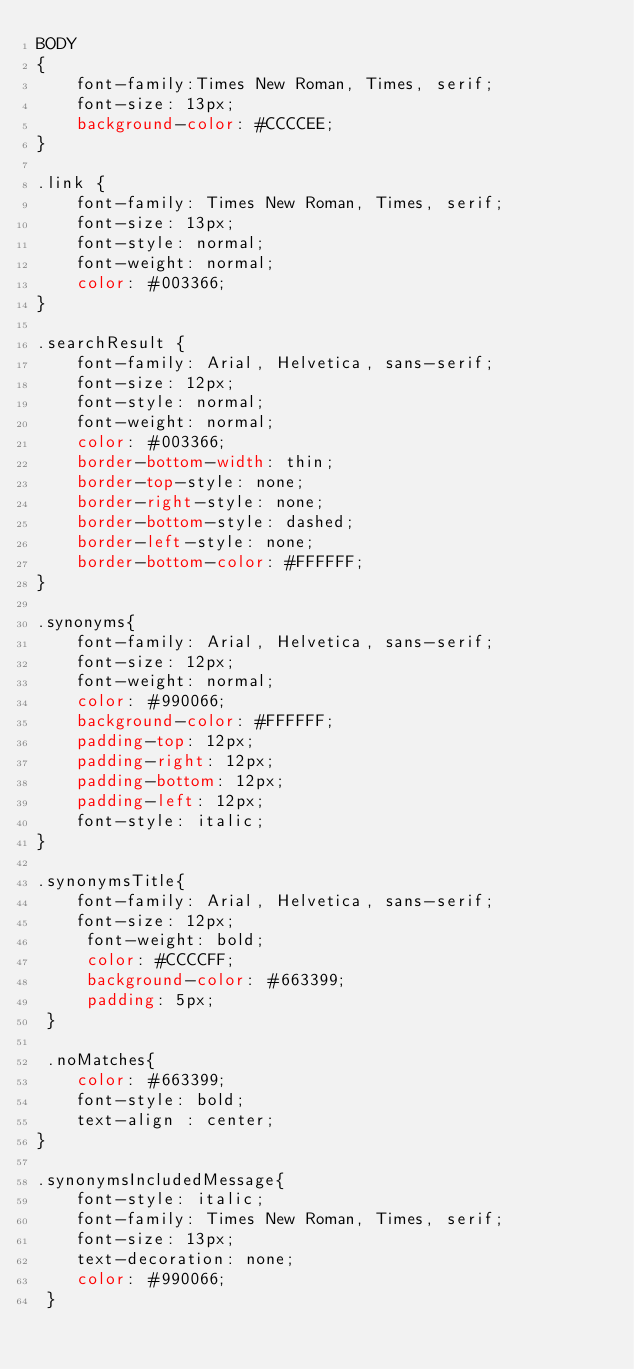<code> <loc_0><loc_0><loc_500><loc_500><_CSS_>BODY 
{
	font-family:Times New Roman, Times, serif;
	font-size: 13px;
	background-color: #CCCCEE;
}

.link {
	font-family: Times New Roman, Times, serif;
	font-size: 13px;
	font-style: normal;
	font-weight: normal;
	color: #003366;
}

.searchResult {
	font-family: Arial, Helvetica, sans-serif;
	font-size: 12px;
	font-style: normal;
	font-weight: normal;
	color: #003366;
	border-bottom-width: thin;
	border-top-style: none;
	border-right-style: none;
	border-bottom-style: dashed;
	border-left-style: none;
	border-bottom-color: #FFFFFF;
}

.synonyms{
	font-family: Arial, Helvetica, sans-serif;
	font-size: 12px;
	font-weight: normal;
	color: #990066;
	background-color: #FFFFFF;
	padding-top: 12px;
	padding-right: 12px;
	padding-bottom: 12px;
	padding-left: 12px;
	font-style: italic;
}

.synonymsTitle{ 
	font-family: Arial, Helvetica, sans-serif; 
	font-size: 12px;
	 font-weight: bold; 
	 color: #CCCCFF; 
 	 background-color: #663399;
	 padding: 5px;
 }
 
 .noMatches{
	color: #663399; 
	font-style: bold; 
	text-align : center; 
}

.synonymsIncludedMessage{
	font-style: italic; 
	font-family: Times New Roman, Times, serif; 
	font-size: 13px; 	
	text-decoration: none; 
	color: #990066;
 } 
</code> 